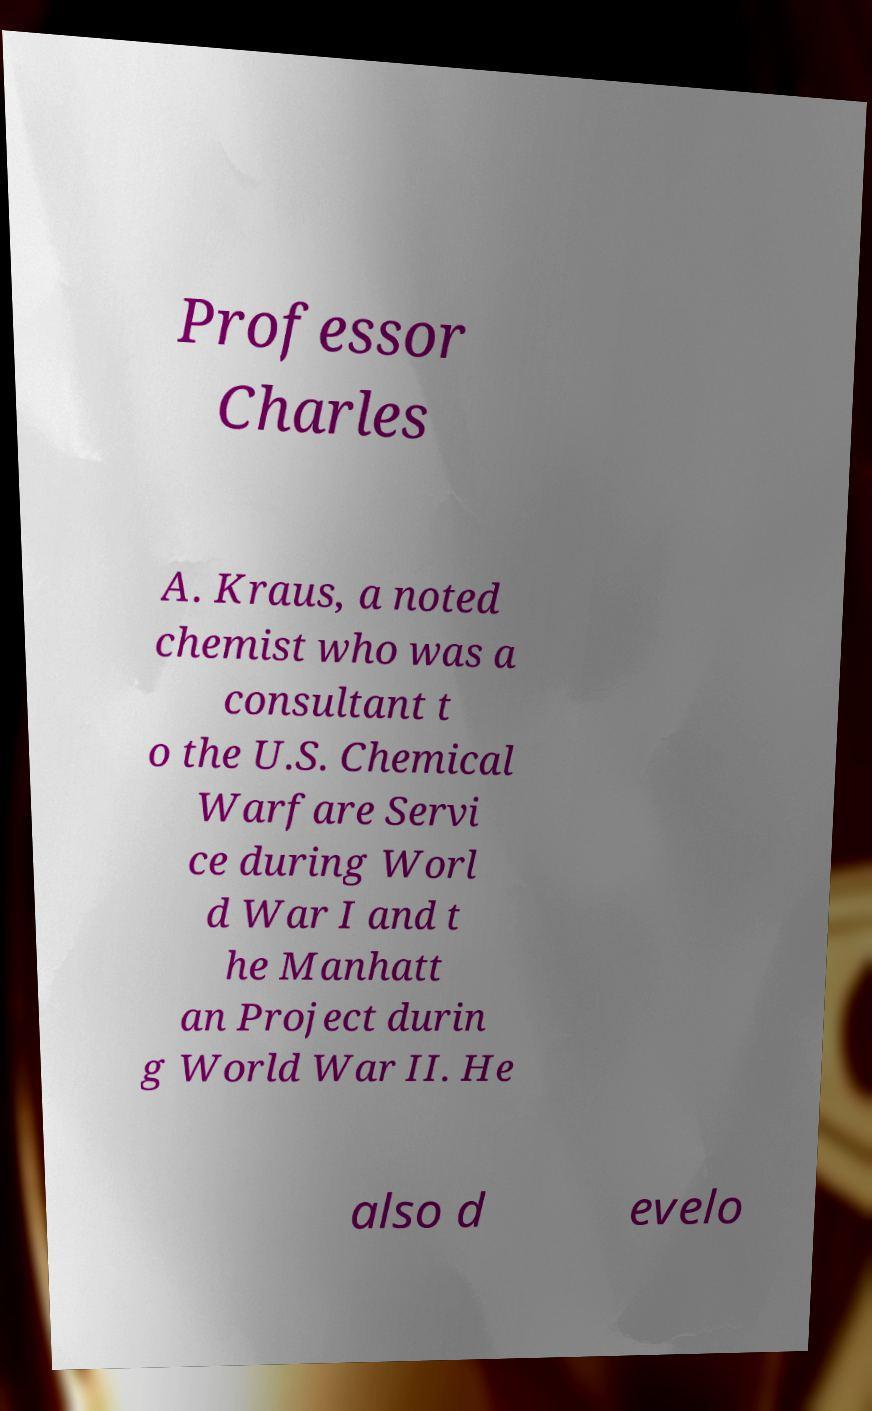Could you extract and type out the text from this image? Professor Charles A. Kraus, a noted chemist who was a consultant t o the U.S. Chemical Warfare Servi ce during Worl d War I and t he Manhatt an Project durin g World War II. He also d evelo 